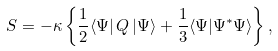Convert formula to latex. <formula><loc_0><loc_0><loc_500><loc_500>S = - \kappa \left \{ \frac { 1 } { 2 } \langle \Psi | \, Q \, | \Psi \rangle + \frac { 1 } { 3 } \langle \Psi | \Psi ^ { * } \Psi \rangle \right \} ,</formula> 